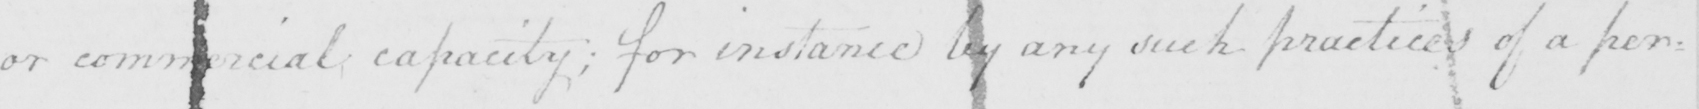Please transcribe the handwritten text in this image. or commercial capacity ; for instance by any such practices of a per= 